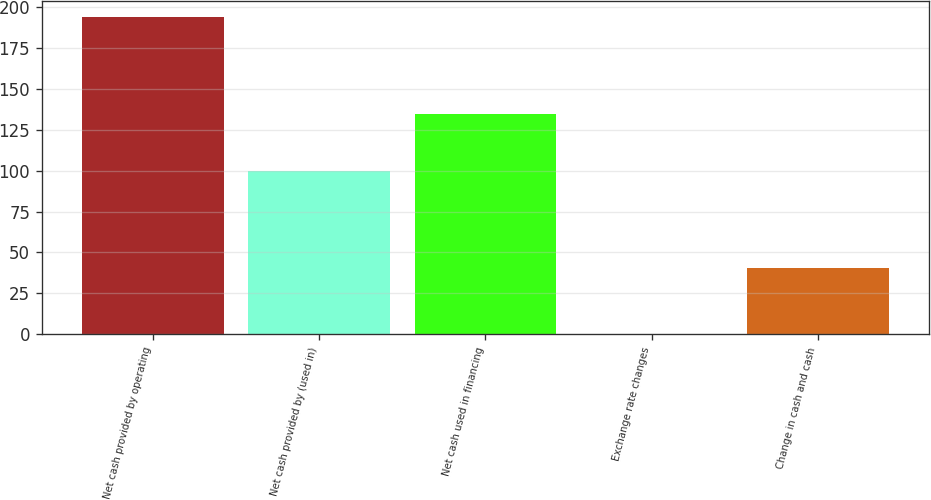<chart> <loc_0><loc_0><loc_500><loc_500><bar_chart><fcel>Net cash provided by operating<fcel>Net cash provided by (used in)<fcel>Net cash used in financing<fcel>Exchange rate changes<fcel>Change in cash and cash<nl><fcel>194<fcel>99.7<fcel>134.8<fcel>0.1<fcel>40.4<nl></chart> 